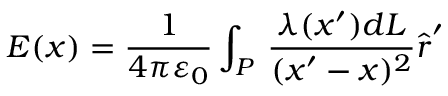Convert formula to latex. <formula><loc_0><loc_0><loc_500><loc_500>{ E } ( { x } ) = { \frac { 1 } { 4 \pi \varepsilon _ { 0 } } } \int _ { P } \, { \frac { \lambda ( { x } ^ { \prime } ) d L } { ( { x } ^ { \prime } - { x } ) ^ { 2 } } } { \hat { r } } ^ { \prime }</formula> 